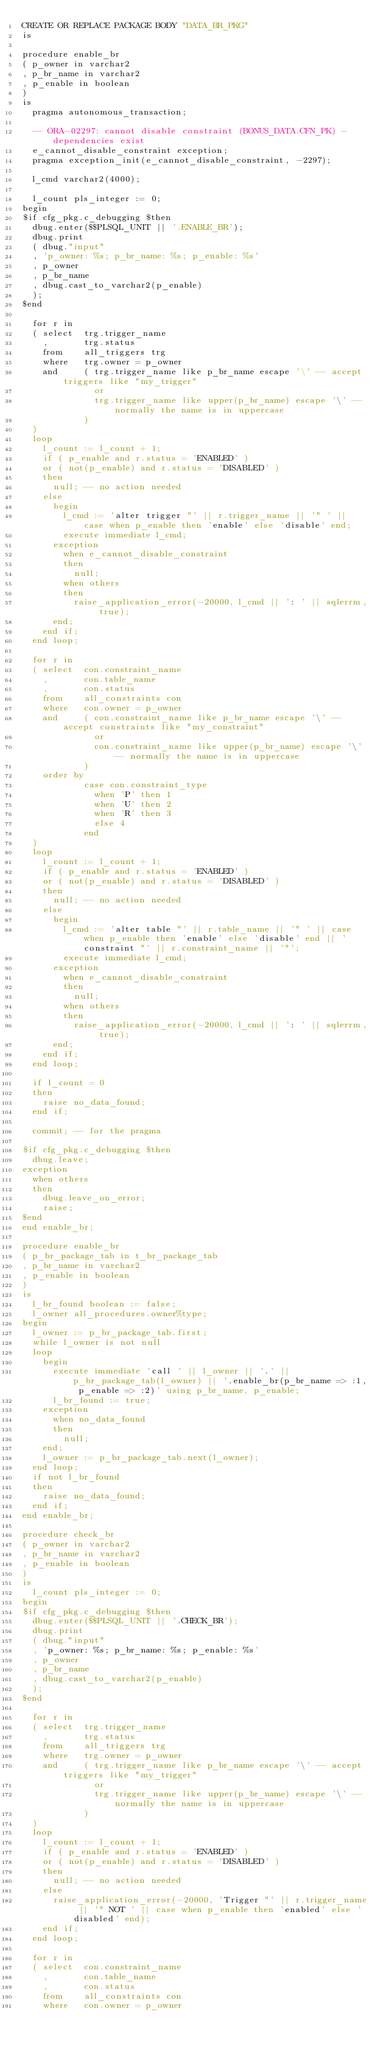<code> <loc_0><loc_0><loc_500><loc_500><_SQL_>CREATE OR REPLACE PACKAGE BODY "DATA_BR_PKG" 
is

procedure enable_br
( p_owner in varchar2
, p_br_name in varchar2
, p_enable in boolean
)
is
  pragma autonomous_transaction;

  -- ORA-02297: cannot disable constraint (BONUS_DATA.CFN_PK) - dependencies exist
  e_cannot_disable_constraint exception;
  pragma exception_init(e_cannot_disable_constraint, -2297);

  l_cmd varchar2(4000);
  
  l_count pls_integer := 0;
begin
$if cfg_pkg.c_debugging $then
  dbug.enter($$PLSQL_UNIT || '.ENABLE_BR');
  dbug.print
  ( dbug."input"
  , 'p_owner: %s; p_br_name: %s; p_enable: %s'
  , p_owner
  , p_br_name
  , dbug.cast_to_varchar2(p_enable)
  );
$end

  for r in
  ( select  trg.trigger_name
    ,       trg.status
    from    all_triggers trg
    where   trg.owner = p_owner
    and     ( trg.trigger_name like p_br_name escape '\' -- accept triggers like "my_trigger"
              or
              trg.trigger_name like upper(p_br_name) escape '\' -- normally the name is in uppercase
            )
  )
  loop
    l_count := l_count + 1;
    if ( p_enable and r.status = 'ENABLED' )
    or ( not(p_enable) and r.status = 'DISABLED' )
    then
      null; -- no action needed
    else
      begin
        l_cmd := 'alter trigger "' || r.trigger_name || '" ' || case when p_enable then 'enable' else 'disable' end;
        execute immediate l_cmd;
      exception
        when e_cannot_disable_constraint
        then
          null;
        when others
        then
          raise_application_error(-20000, l_cmd || ': ' || sqlerrm, true);
      end;
    end if;
  end loop;

  for r in
  ( select  con.constraint_name
    ,       con.table_name
    ,       con.status
    from    all_constraints con
    where   con.owner = p_owner
    and     ( con.constraint_name like p_br_name escape '\' -- accept constraints like "my_constraint"
              or
              con.constraint_name like upper(p_br_name) escape '\' -- normally the name is in uppercase
            )
    order by
            case con.constraint_type
              when 'P' then 1
              when 'U' then 2
              when 'R' then 3
              else 4
            end
  )
  loop
    l_count := l_count + 1;
    if ( p_enable and r.status = 'ENABLED' )
    or ( not(p_enable) and r.status = 'DISABLED' )
    then
      null; -- no action needed
    else
      begin
        l_cmd := 'alter table "' || r.table_name || '" ' || case when p_enable then 'enable' else 'disable' end || ' constraint "' || r.constraint_name || '"';
        execute immediate l_cmd;
      exception
        when e_cannot_disable_constraint
        then
          null;
        when others
        then
          raise_application_error(-20000, l_cmd || ': ' || sqlerrm, true);
      end;
    end if;
  end loop;

  if l_count = 0
  then
    raise no_data_found;
  end if;

  commit; -- for the pragma

$if cfg_pkg.c_debugging $then
  dbug.leave;
exception
  when others
  then
    dbug.leave_on_error;
    raise;
$end
end enable_br;

procedure enable_br
( p_br_package_tab in t_br_package_tab
, p_br_name in varchar2
, p_enable in boolean
)
is
  l_br_found boolean := false;
  l_owner all_procedures.owner%type;
begin  
  l_owner := p_br_package_tab.first;
  while l_owner is not null
  loop
    begin
      execute immediate 'call ' || l_owner || '.' || p_br_package_tab(l_owner) || '.enable_br(p_br_name => :1, p_enable => :2)' using p_br_name, p_enable;
      l_br_found := true;
    exception
      when no_data_found
      then
        null;
    end;
    l_owner := p_br_package_tab.next(l_owner);
  end loop;
  if not l_br_found
  then
    raise no_data_found;
  end if;
end enable_br;  

procedure check_br
( p_owner in varchar2
, p_br_name in varchar2
, p_enable in boolean
)
is
  l_count pls_integer := 0;
begin
$if cfg_pkg.c_debugging $then
  dbug.enter($$PLSQL_UNIT || '.CHECK_BR');
  dbug.print
  ( dbug."input"
  , 'p_owner: %s; p_br_name: %s; p_enable: %s'
  , p_owner
  , p_br_name
  , dbug.cast_to_varchar2(p_enable)
  );
$end

  for r in
  ( select  trg.trigger_name
    ,       trg.status
    from    all_triggers trg
    where   trg.owner = p_owner
    and     ( trg.trigger_name like p_br_name escape '\' -- accept triggers like "my_trigger"
              or
              trg.trigger_name like upper(p_br_name) escape '\' -- normally the name is in uppercase
            )
  )
  loop
    l_count := l_count + 1;
    if ( p_enable and r.status = 'ENABLED' )
    or ( not(p_enable) and r.status = 'DISABLED' )
    then
      null; -- no action needed
    else
      raise_application_error(-20000, 'Trigger "' || r.trigger_name || '" NOT ' || case when p_enable then 'enabled' else 'disabled' end);
    end if;
  end loop;

  for r in
  ( select  con.constraint_name
    ,       con.table_name
    ,       con.status
    from    all_constraints con
    where   con.owner = p_owner</code> 